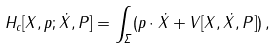<formula> <loc_0><loc_0><loc_500><loc_500>H _ { c } [ X , p ; \dot { X } , P ] = \int _ { \Sigma } ( p \cdot \dot { X } + V [ X , \dot { X } , P ] ) \, ,</formula> 